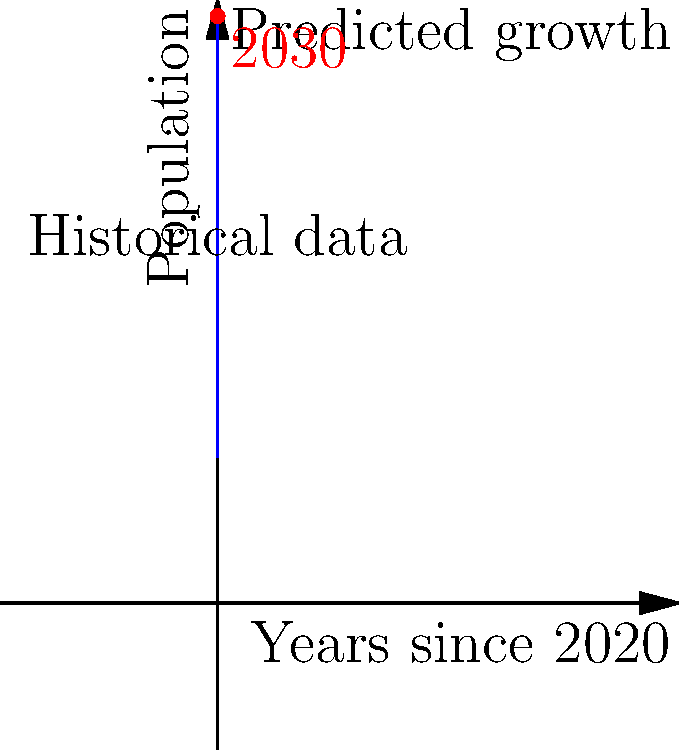Based on the graph showing historical population data and predicted growth for your city, what would be the estimated population in 2030 (10 years from the start of the data)? How might this information influence your resource allocation and tax revenue strategies? To answer this question, we need to analyze the graph and extract the relevant information:

1. The x-axis represents years since 2020, and the y-axis represents the population.
2. The blue curve shows both historical data and predicted growth.
3. The red dot on the curve indicates the population estimate for 2030 (10 years from the start).

To find the estimated population in 2030:
1. Locate the red dot on the graph, which represents the year 2030.
2. Estimate the y-value corresponding to this point.

From the graph, we can estimate that the population in 2030 will be approximately 300,000.

This information can influence resource allocation and tax revenue strategies in several ways:
1. Infrastructure planning: Anticipate the need for expanded public services, transportation, and housing to accommodate the growing population.
2. Budget forecasting: Project increased tax revenue based on population growth, but also account for higher expenses in public services.
3. Economic development: Plan for job creation and business growth to support the larger population.
4. Zoning and urban planning: Adjust land use policies to accommodate population density changes.
5. Environmental considerations: Develop strategies to manage increased resource consumption and waste production.

By using this population growth prediction, the mayor can make data-driven decisions to ensure the city's resources are allocated efficiently and tax revenues are maximized to meet the needs of the growing population.
Answer: Estimated population in 2030: 300,000. Influences: infrastructure planning, budget forecasting, economic development, urban planning, and environmental management. 